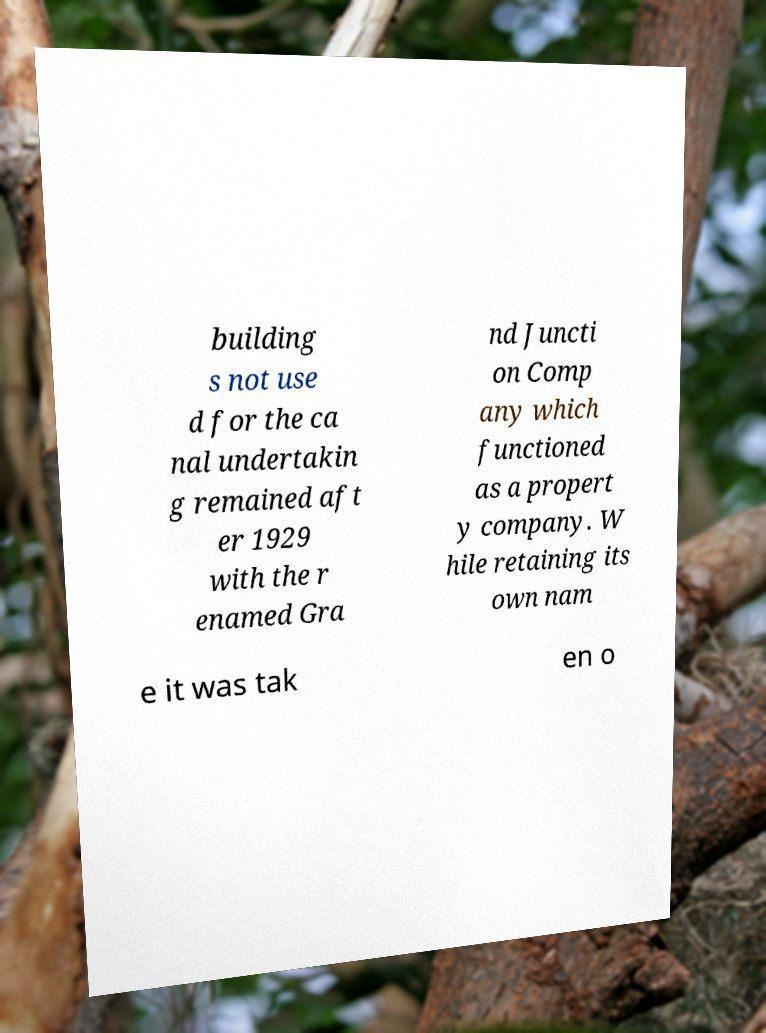Can you accurately transcribe the text from the provided image for me? building s not use d for the ca nal undertakin g remained aft er 1929 with the r enamed Gra nd Juncti on Comp any which functioned as a propert y company. W hile retaining its own nam e it was tak en o 